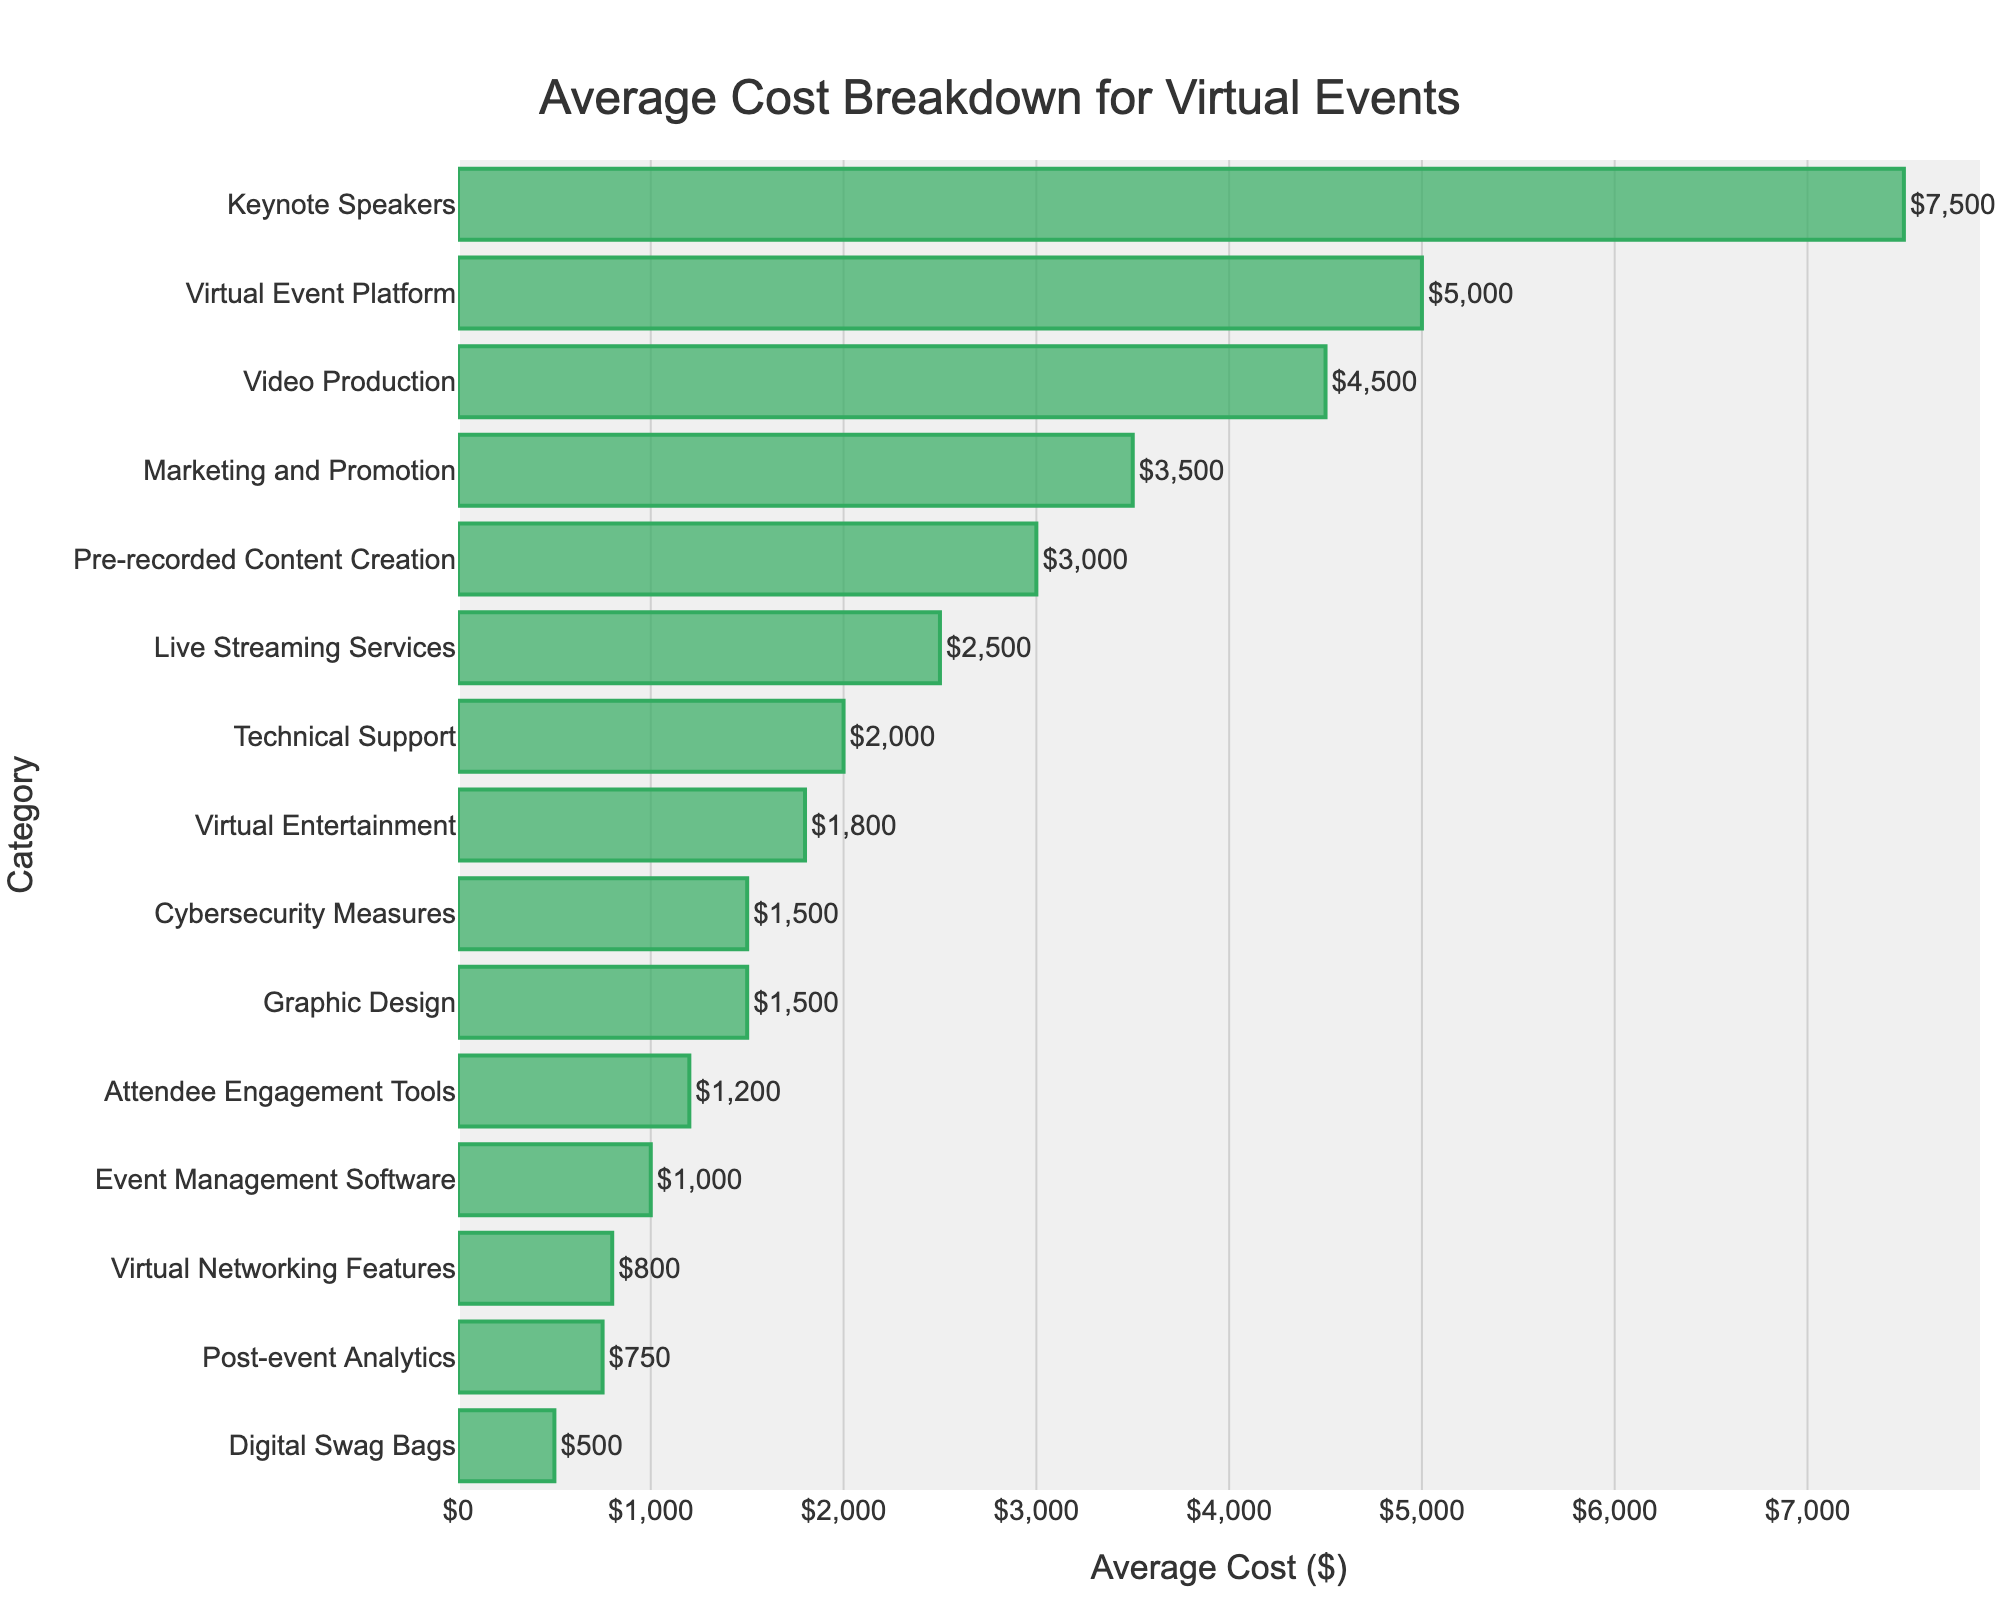What's the highest cost category? The highest cost category is identified by looking for the tallest bar in the chart. This is "Keynote Speakers" at $7,500.
Answer: Keynote Speakers What's the lowest cost category? The lowest cost category is identified by looking for the shortest bar in the chart. This is "Digital Swag Bags" at $500.
Answer: Digital Swag Bags How much more expensive are Keynote Speakers compared to Virtual Entertainment? The cost of Keynote Speakers is $7,500, and the cost of Virtual Entertainment is $1,800. Subtract the latter from the former: $7,500 - $1,800.
Answer: $5,700 What is the total cost for Technical Support, Video Production, and Cybersecurity Measures combined? Add the costs of Technical Support ($2,000), Video Production ($4,500), and Cybersecurity Measures ($1,500). The sum is $2,000 + $4,500 + $1,500.
Answer: $8,000 Which category has a higher cost: Pre-recorded Content Creation or Live Streaming Services? Compare the costs for Pre-recorded Content Creation ($3,000) and Live Streaming Services ($2,500). The former is higher.
Answer: Pre-recorded Content Creation How many categories cost more than $3,000? Count the number of categories where the bar represents a cost greater than $3,000. They are "Pre-recorded Content Creation," "Video Production," "Marketing and Promotion," "Virtual Event Platform," and "Keynote Speakers."
Answer: 5 By how much does Marketing and Promotion exceed the cost of Graphic Design and Virtual Networking Features combined? Marketing and Promotion cost is $3,500. The combined cost of Graphic Design ($1,500) and Virtual Networking Features ($800) is $1,500 + $800 = $2,300. Subtract to find the difference: $3,500 - $2,300.
Answer: $1,200 What is the average cost of the three most expensive categories? The three most expensive categories are "Keynote Speakers" ($7,500), "Virtual Event Platform" ($5,000), and "Video Production" ($4,500). Calculate the average by adding these costs and dividing by 3: (7,500 + 5,000 + 4,500) / 3.
Answer: $5,667 Which category is represented by the third highest bar? The third highest bar corresponds to "Video Production" priced at $4,500.
Answer: Video Production 